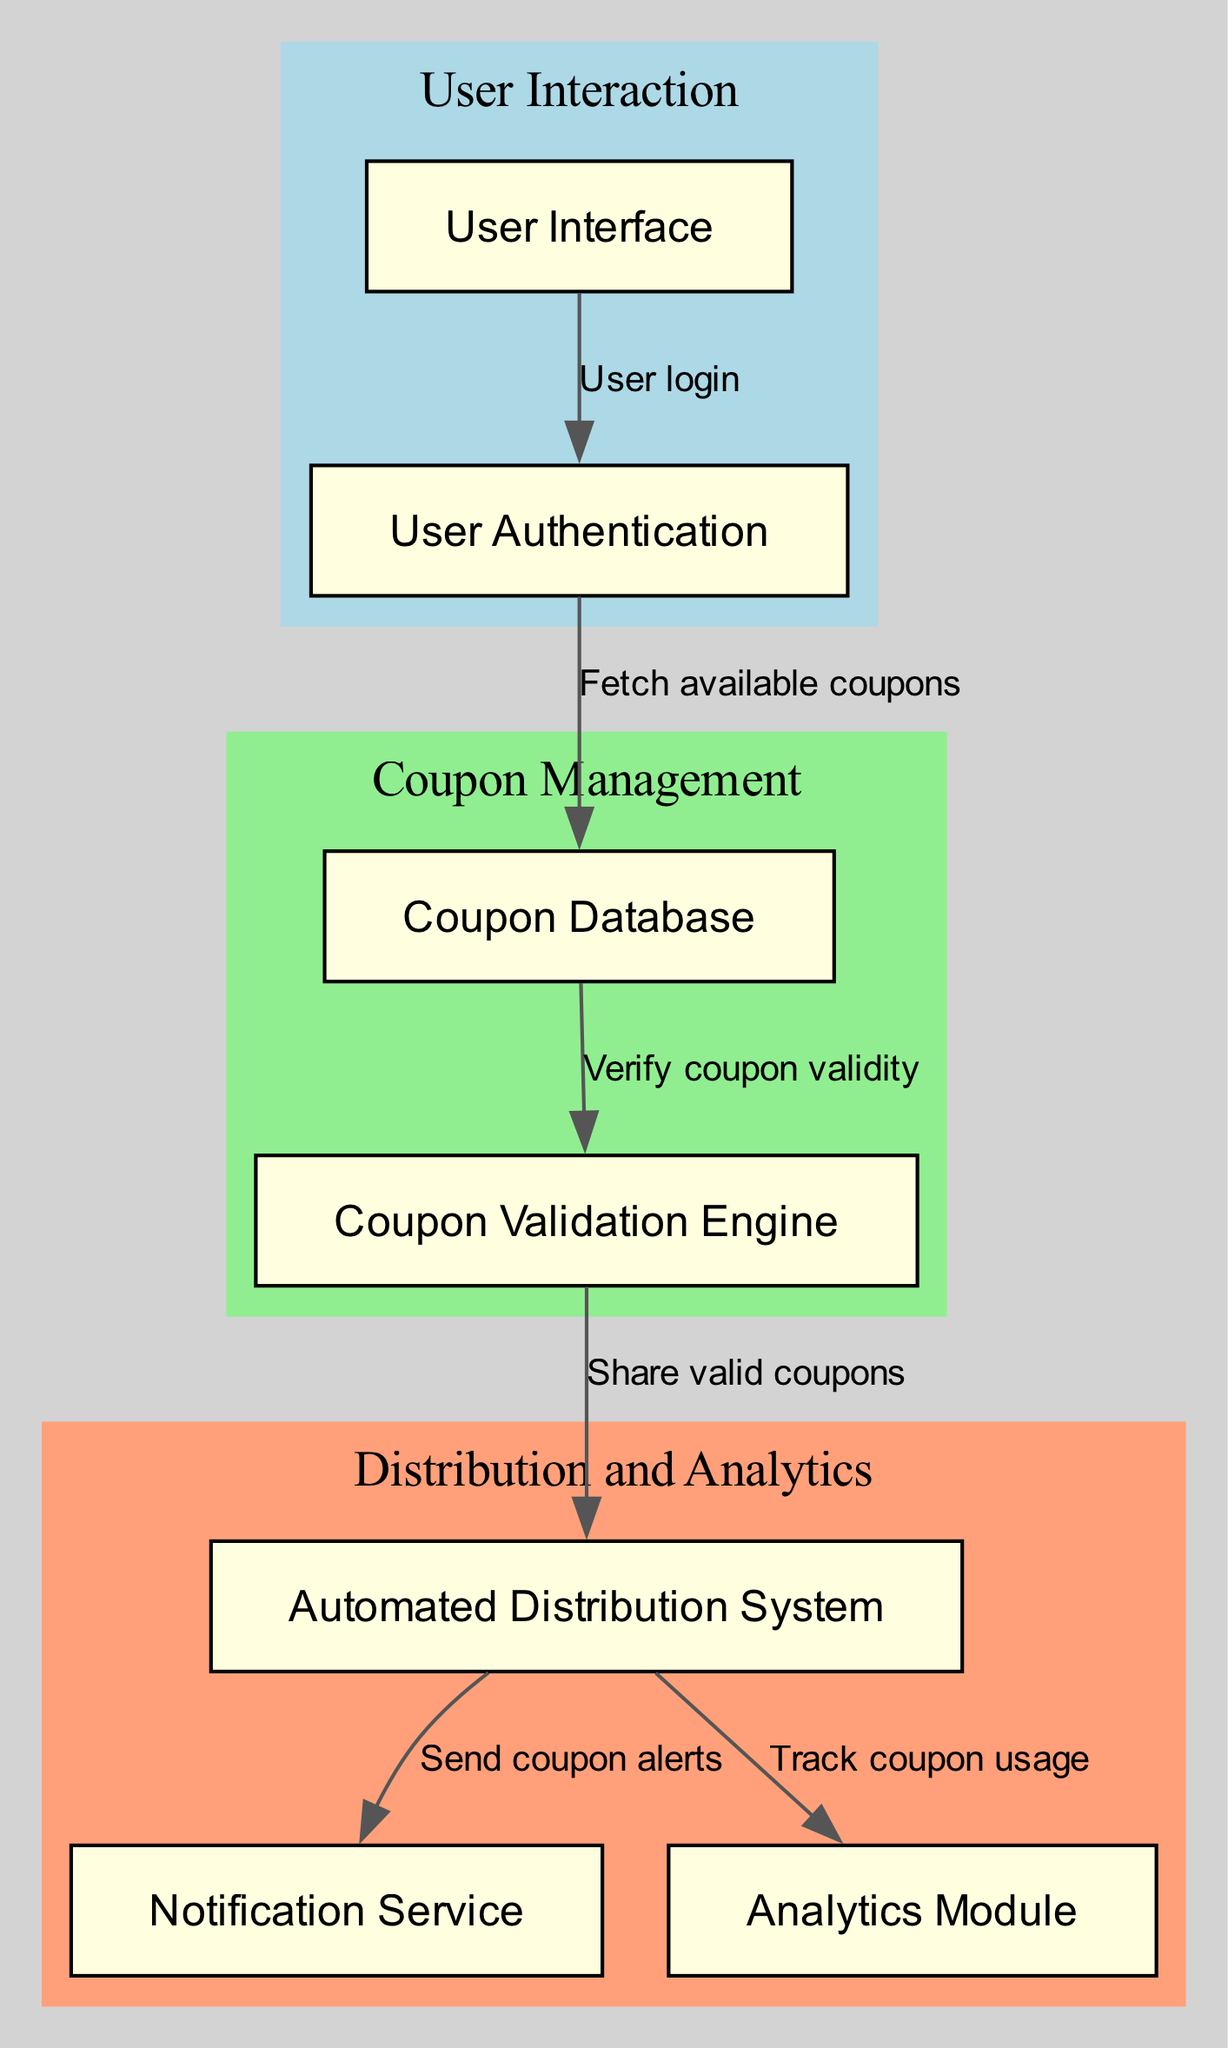What is the total number of nodes in the diagram? The diagram contains a list of nodes: User Interface, User Authentication, Coupon Database, Coupon Validation Engine, Automated Distribution System, Notification Service, and Analytics Module. Counting these, we find there are 7 nodes total.
Answer: 7 What is the label of the node that represents user authentication? In the diagram, the node labeled "User Authentication" is explicitly listed among the nodes. Therefore, the answer is directly found in the diagram's data.
Answer: User Authentication Which node comes after the "Coupon Database"? Following the flow from the "Coupon Database," the next node in the sequence is "Coupon Validation Engine." This is derived from the edges that connect these nodes.
Answer: Coupon Validation Engine What is sent to the Notification Service from the Distribution System? According to the edges from the "Distribution System," the "Send coupon alerts" connects to the "Notification Service." Thus, the output sent to the Notification Service is coupon alerts.
Answer: Coupon alerts How many edges connect the nodes in the diagram? The diagram lists the connections (edges), detailing the relationships between the nodes. Counting these edges, we find there are 6 connections in total.
Answer: 6 What is the purpose of the Analytics Module in the system? The flow indicates that the "Analytics Module" receives information from the "Distribution System" labeled as "Track coupon usage." Hence, its purpose is for tracking coupon usage.
Answer: Track coupon usage What do users need to do first to access coupons? The diagram shows that users start at the "User Interface," which indicates the initial action of user login required for accessing coupons.
Answer: User login Which components are grouped under "Coupon Management"? The two nodes that fall under the "Coupon Management" cluster are "Coupon Database" and "Coupon Validation Engine." This group is defined clearly within the subgraphs of the diagram.
Answer: Coupon Database, Coupon Validation Engine 